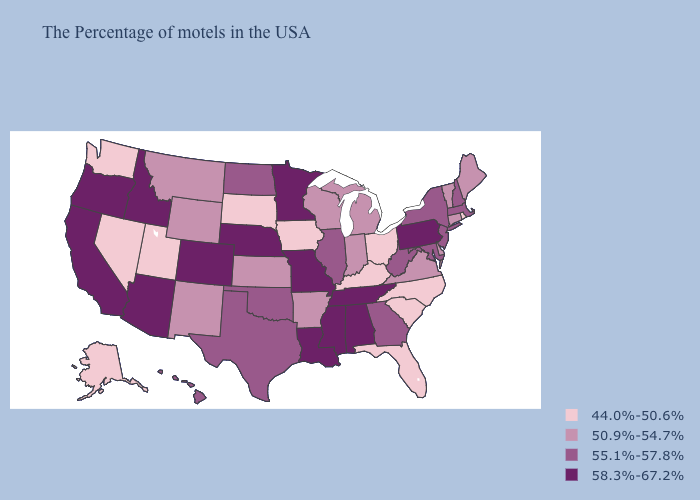Does North Dakota have the lowest value in the USA?
Give a very brief answer. No. Among the states that border Rhode Island , does Connecticut have the highest value?
Write a very short answer. No. What is the highest value in the South ?
Answer briefly. 58.3%-67.2%. What is the value of Vermont?
Keep it brief. 50.9%-54.7%. Does Massachusetts have a lower value than Virginia?
Short answer required. No. Name the states that have a value in the range 58.3%-67.2%?
Quick response, please. Pennsylvania, Alabama, Tennessee, Mississippi, Louisiana, Missouri, Minnesota, Nebraska, Colorado, Arizona, Idaho, California, Oregon. Does Maryland have the highest value in the USA?
Give a very brief answer. No. Name the states that have a value in the range 55.1%-57.8%?
Concise answer only. Massachusetts, New Hampshire, New York, New Jersey, Maryland, West Virginia, Georgia, Illinois, Oklahoma, Texas, North Dakota, Hawaii. What is the value of Kentucky?
Write a very short answer. 44.0%-50.6%. Among the states that border Pennsylvania , which have the highest value?
Quick response, please. New York, New Jersey, Maryland, West Virginia. Among the states that border Kentucky , which have the highest value?
Give a very brief answer. Tennessee, Missouri. Name the states that have a value in the range 50.9%-54.7%?
Quick response, please. Maine, Vermont, Connecticut, Delaware, Virginia, Michigan, Indiana, Wisconsin, Arkansas, Kansas, Wyoming, New Mexico, Montana. Name the states that have a value in the range 58.3%-67.2%?
Be succinct. Pennsylvania, Alabama, Tennessee, Mississippi, Louisiana, Missouri, Minnesota, Nebraska, Colorado, Arizona, Idaho, California, Oregon. What is the value of Nebraska?
Be succinct. 58.3%-67.2%. What is the value of Louisiana?
Give a very brief answer. 58.3%-67.2%. 